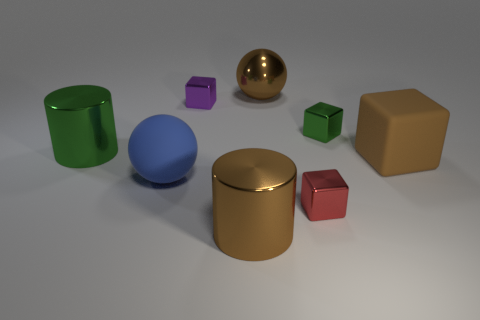Subtract all red cubes. How many cubes are left? 3 Subtract all yellow cubes. Subtract all red spheres. How many cubes are left? 4 Add 2 big blue spheres. How many objects exist? 10 Subtract all balls. How many objects are left? 6 Add 1 big blue matte objects. How many big blue matte objects are left? 2 Add 2 green metallic cylinders. How many green metallic cylinders exist? 3 Subtract 0 blue cubes. How many objects are left? 8 Subtract all large blue rubber spheres. Subtract all cyan matte cubes. How many objects are left? 7 